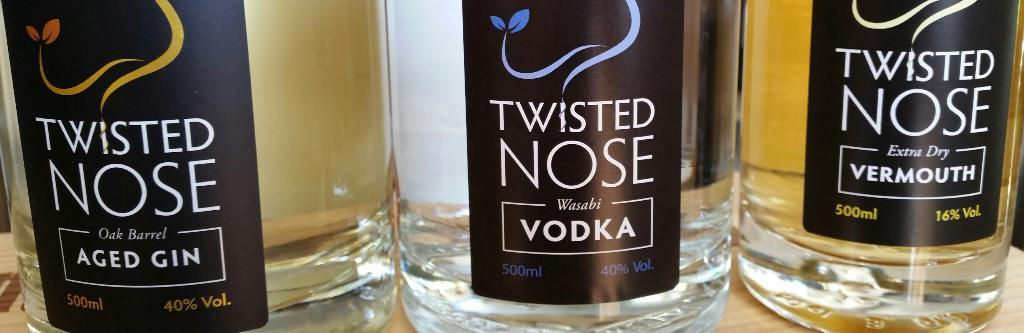How many wine bottles are in the image? There are three wine bottles in the image. What is the capacity of each wine bottle? Each wine bottle is 500 ml. What type of spacecraft can be seen in the image? There is no spacecraft present in the image; it features three wine bottles. What type of play equipment is visible in the image? There is no play equipment present in the image; it features three wine bottles. 